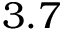Convert formula to latex. <formula><loc_0><loc_0><loc_500><loc_500>3 . 7</formula> 